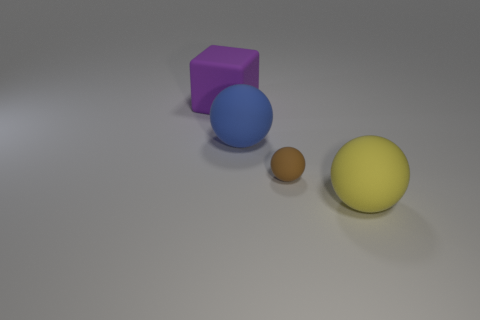What shape is the yellow matte thing?
Provide a short and direct response. Sphere. There is a object that is right of the blue matte sphere and on the left side of the large yellow thing; how big is it?
Give a very brief answer. Small. There is a large thing that is in front of the blue object; what is its material?
Make the answer very short. Rubber. There is a matte block; is its color the same as the rubber thing that is to the right of the tiny brown sphere?
Your answer should be very brief. No. What number of things are matte balls that are on the right side of the blue thing or brown rubber objects that are right of the block?
Make the answer very short. 2. What is the color of the rubber object that is on the left side of the big yellow rubber ball and in front of the large blue matte thing?
Provide a short and direct response. Brown. Are there more matte things than tiny red cylinders?
Your response must be concise. Yes. There is a large rubber thing in front of the small matte object; does it have the same shape as the purple object?
Offer a terse response. No. How many rubber objects are yellow things or large red things?
Your answer should be very brief. 1. Is there a blue sphere that has the same material as the big purple thing?
Provide a short and direct response. Yes. 